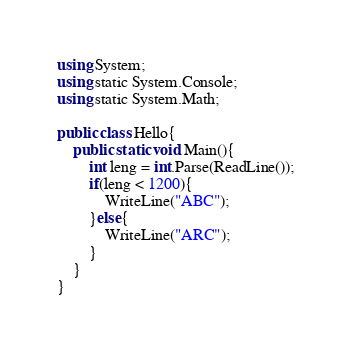Convert code to text. <code><loc_0><loc_0><loc_500><loc_500><_C#_>using System;
using static System.Console;
using static System.Math;

public class Hello{
    public static void Main(){
        int leng = int.Parse(ReadLine());
        if(leng < 1200){
            WriteLine("ABC");
        }else{
            WriteLine("ARC");
        }
    }
}
</code> 